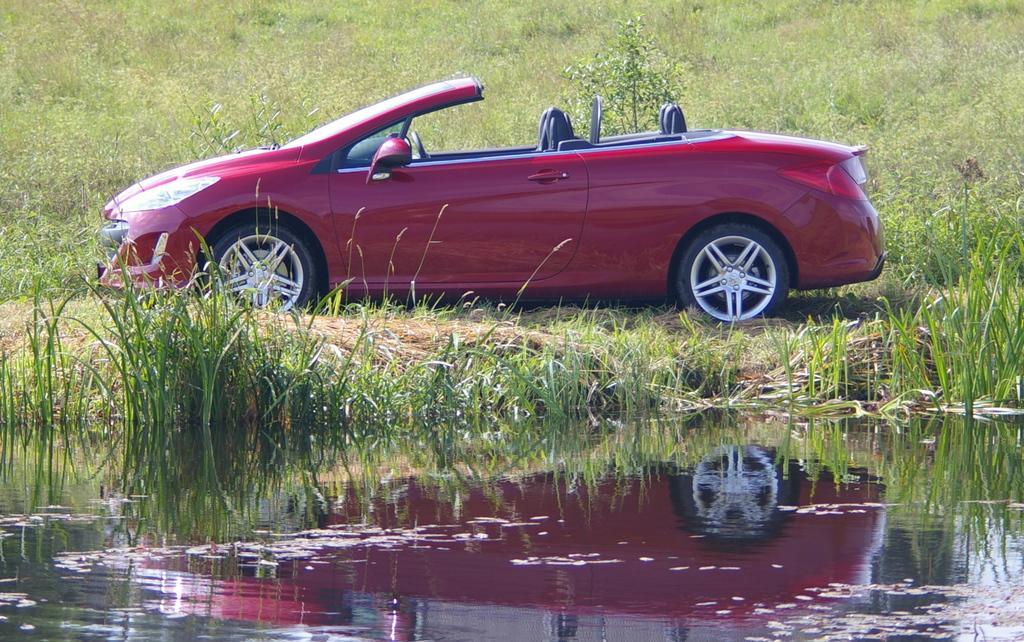Could you give a brief overview of what you see in this image? In the center of the image there is a red color car. In the background of the image there is grass. At the bottom of the image there is water in which there is a reflection of a car. 